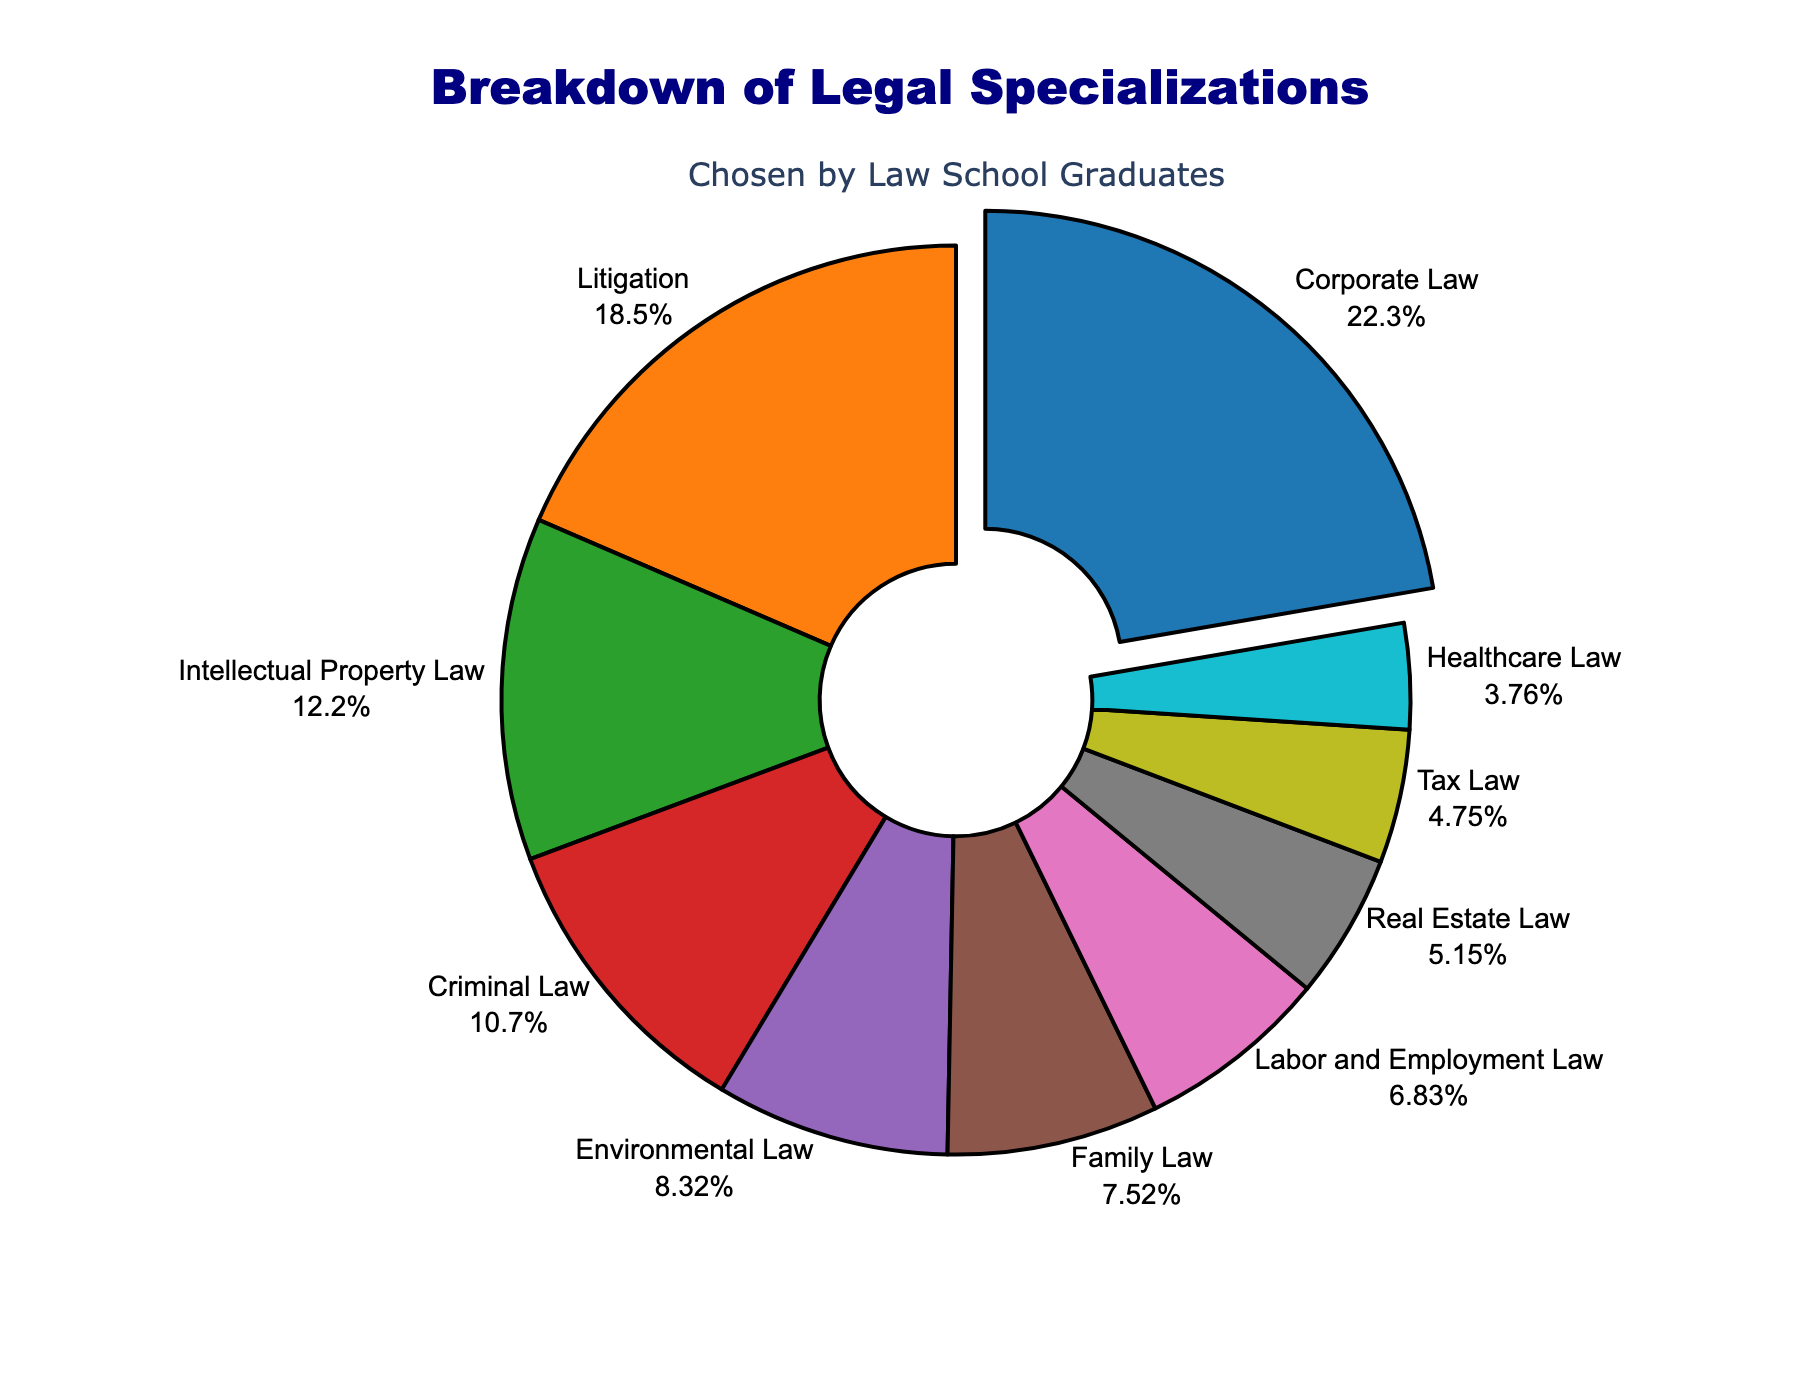What percentage of law graduates chose Corporate Law? The figure shows that Corporate Law is highlighted, with a visual text indicating its percentage. Verify from the labeled slice that Corporate Law has 22.5% share.
Answer: 22.5% Which legal specialization has the smallest percentage of graduates? To determine the smallest percentage, locate the smallest slice in the pie chart and read the label. The smallest slice is for Healthcare Law.
Answer: Healthcare Law How much larger is the percentage for Corporate Law compared to Litigation? To compare, find both percentages from the chart. Corporate Law is 22.5% and Litigation is 18.7%. Subtract Litigation percentage from Corporate Law's. 22.5% - 18.7% = 3.8%.
Answer: 3.8% What is the combined percentage of graduates choosing Criminal Law and Environmental Law? Add the percentages for Criminal Law (10.8%) and Environmental Law (8.4%) from the chart. 10.8% + 8.4% = 19.2%.
Answer: 19.2% Which specialization is represented by the purple slice and what percentage does it have? Identify the purple slice by its visual attribute and check its label. The purple slice corresponds to Intellectual Property Law with 12.3%.
Answer: Intellectual Property Law, 12.3% How does the percentage of graduates choosing Family Law compare with those choosing Labor and Employment Law? Find the percentages for both specializations: Family Law (7.6%) and Labor and Employment Law (6.9%). Compare directly to see that Family Law is larger.
Answer: Family Law is larger What is the total percentage of graduates choosing either Tax Law or Real Estate Law? Sum the percentages for Tax Law (4.8%) and Real Estate Law (5.2%) from the chart. 4.8% + 5.2% = 10%.
Answer: 10% Are there more graduates choosing Intellectual Property Law than Environmental Law? Compare the percentages for Intellectual Property Law (12.3%) and Environmental Law (8.4%) from the chart to see that Intellectual Property Law has a higher percentage.
Answer: Yes Which specialization has exactly half the percentage compared to Corporate Law? Determine the percentage that is half of Corporate Law (22.5%/2 = 11.25%), then find the specialization that approximates this value. None exactly fit 11.25%, closest is Intellectual Property Law at 12.3%.
Answer: None exactly, closest is Intellectual Property Law What is the total percentage for the top three specializations? Identify the top three percentages: Corporate Law (22.5%), Litigation (18.7%), and Intellectual Property Law (12.3%). Sum these values. 22.5% + 18.7% + 12.3% = 53.5%.
Answer: 53.5% 